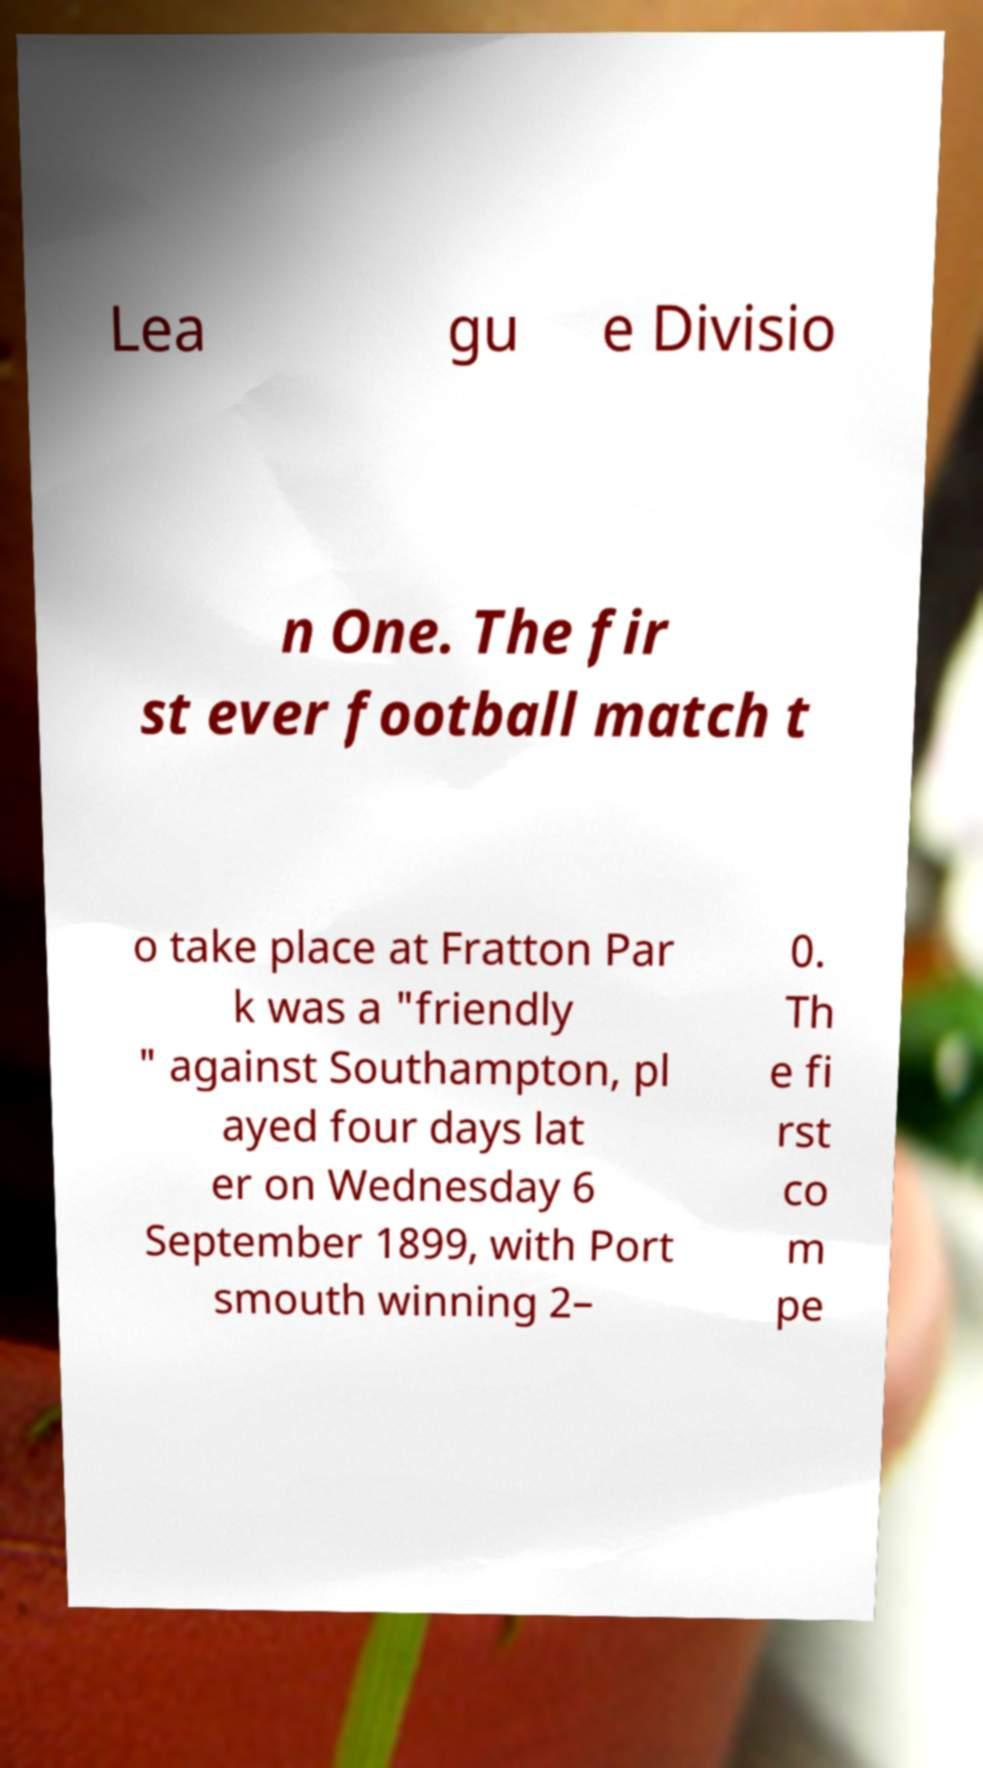Can you read and provide the text displayed in the image?This photo seems to have some interesting text. Can you extract and type it out for me? Lea gu e Divisio n One. The fir st ever football match t o take place at Fratton Par k was a "friendly " against Southampton, pl ayed four days lat er on Wednesday 6 September 1899, with Port smouth winning 2– 0. Th e fi rst co m pe 